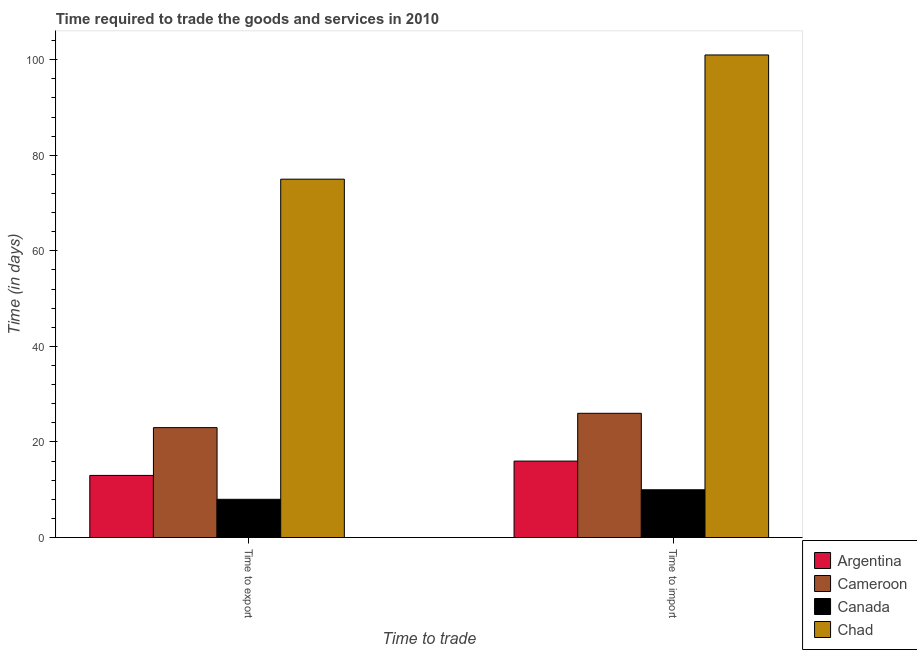Are the number of bars on each tick of the X-axis equal?
Your response must be concise. Yes. How many bars are there on the 2nd tick from the right?
Ensure brevity in your answer.  4. What is the label of the 1st group of bars from the left?
Make the answer very short. Time to export. What is the time to import in Canada?
Offer a terse response. 10. Across all countries, what is the maximum time to import?
Offer a terse response. 101. Across all countries, what is the minimum time to export?
Provide a short and direct response. 8. In which country was the time to import maximum?
Your response must be concise. Chad. In which country was the time to export minimum?
Offer a terse response. Canada. What is the total time to export in the graph?
Offer a very short reply. 119. What is the difference between the time to import in Canada and that in Argentina?
Keep it short and to the point. -6. What is the difference between the time to import in Cameroon and the time to export in Chad?
Keep it short and to the point. -49. What is the average time to import per country?
Your response must be concise. 38.25. What is the difference between the time to export and time to import in Canada?
Keep it short and to the point. -2. In how many countries, is the time to import greater than 28 days?
Offer a terse response. 1. What does the 2nd bar from the left in Time to import represents?
Give a very brief answer. Cameroon. What does the 3rd bar from the right in Time to export represents?
Keep it short and to the point. Cameroon. How many bars are there?
Keep it short and to the point. 8. Are all the bars in the graph horizontal?
Your response must be concise. No. How many countries are there in the graph?
Your response must be concise. 4. Does the graph contain any zero values?
Provide a succinct answer. No. How many legend labels are there?
Give a very brief answer. 4. How are the legend labels stacked?
Ensure brevity in your answer.  Vertical. What is the title of the graph?
Offer a very short reply. Time required to trade the goods and services in 2010. Does "Benin" appear as one of the legend labels in the graph?
Ensure brevity in your answer.  No. What is the label or title of the X-axis?
Keep it short and to the point. Time to trade. What is the label or title of the Y-axis?
Provide a short and direct response. Time (in days). What is the Time (in days) of Argentina in Time to export?
Offer a very short reply. 13. What is the Time (in days) in Argentina in Time to import?
Your answer should be compact. 16. What is the Time (in days) in Cameroon in Time to import?
Your answer should be compact. 26. What is the Time (in days) in Canada in Time to import?
Give a very brief answer. 10. What is the Time (in days) of Chad in Time to import?
Provide a succinct answer. 101. Across all Time to trade, what is the maximum Time (in days) of Argentina?
Provide a short and direct response. 16. Across all Time to trade, what is the maximum Time (in days) of Cameroon?
Your answer should be compact. 26. Across all Time to trade, what is the maximum Time (in days) of Chad?
Keep it short and to the point. 101. Across all Time to trade, what is the minimum Time (in days) of Argentina?
Ensure brevity in your answer.  13. Across all Time to trade, what is the minimum Time (in days) in Cameroon?
Provide a short and direct response. 23. Across all Time to trade, what is the minimum Time (in days) in Chad?
Your answer should be compact. 75. What is the total Time (in days) of Argentina in the graph?
Ensure brevity in your answer.  29. What is the total Time (in days) of Cameroon in the graph?
Provide a succinct answer. 49. What is the total Time (in days) in Canada in the graph?
Your answer should be very brief. 18. What is the total Time (in days) of Chad in the graph?
Ensure brevity in your answer.  176. What is the difference between the Time (in days) of Cameroon in Time to export and that in Time to import?
Your answer should be very brief. -3. What is the difference between the Time (in days) in Argentina in Time to export and the Time (in days) in Canada in Time to import?
Offer a very short reply. 3. What is the difference between the Time (in days) of Argentina in Time to export and the Time (in days) of Chad in Time to import?
Your answer should be compact. -88. What is the difference between the Time (in days) in Cameroon in Time to export and the Time (in days) in Chad in Time to import?
Keep it short and to the point. -78. What is the difference between the Time (in days) in Canada in Time to export and the Time (in days) in Chad in Time to import?
Offer a terse response. -93. What is the average Time (in days) of Cameroon per Time to trade?
Make the answer very short. 24.5. What is the average Time (in days) of Canada per Time to trade?
Your answer should be very brief. 9. What is the difference between the Time (in days) of Argentina and Time (in days) of Chad in Time to export?
Give a very brief answer. -62. What is the difference between the Time (in days) of Cameroon and Time (in days) of Canada in Time to export?
Give a very brief answer. 15. What is the difference between the Time (in days) in Cameroon and Time (in days) in Chad in Time to export?
Your response must be concise. -52. What is the difference between the Time (in days) in Canada and Time (in days) in Chad in Time to export?
Offer a very short reply. -67. What is the difference between the Time (in days) of Argentina and Time (in days) of Chad in Time to import?
Keep it short and to the point. -85. What is the difference between the Time (in days) of Cameroon and Time (in days) of Canada in Time to import?
Your answer should be compact. 16. What is the difference between the Time (in days) of Cameroon and Time (in days) of Chad in Time to import?
Make the answer very short. -75. What is the difference between the Time (in days) of Canada and Time (in days) of Chad in Time to import?
Provide a short and direct response. -91. What is the ratio of the Time (in days) in Argentina in Time to export to that in Time to import?
Your answer should be compact. 0.81. What is the ratio of the Time (in days) of Cameroon in Time to export to that in Time to import?
Offer a very short reply. 0.88. What is the ratio of the Time (in days) in Chad in Time to export to that in Time to import?
Your answer should be compact. 0.74. What is the difference between the highest and the second highest Time (in days) of Argentina?
Give a very brief answer. 3. What is the difference between the highest and the second highest Time (in days) in Chad?
Provide a succinct answer. 26. What is the difference between the highest and the lowest Time (in days) of Argentina?
Provide a succinct answer. 3. What is the difference between the highest and the lowest Time (in days) in Canada?
Ensure brevity in your answer.  2. What is the difference between the highest and the lowest Time (in days) in Chad?
Provide a succinct answer. 26. 